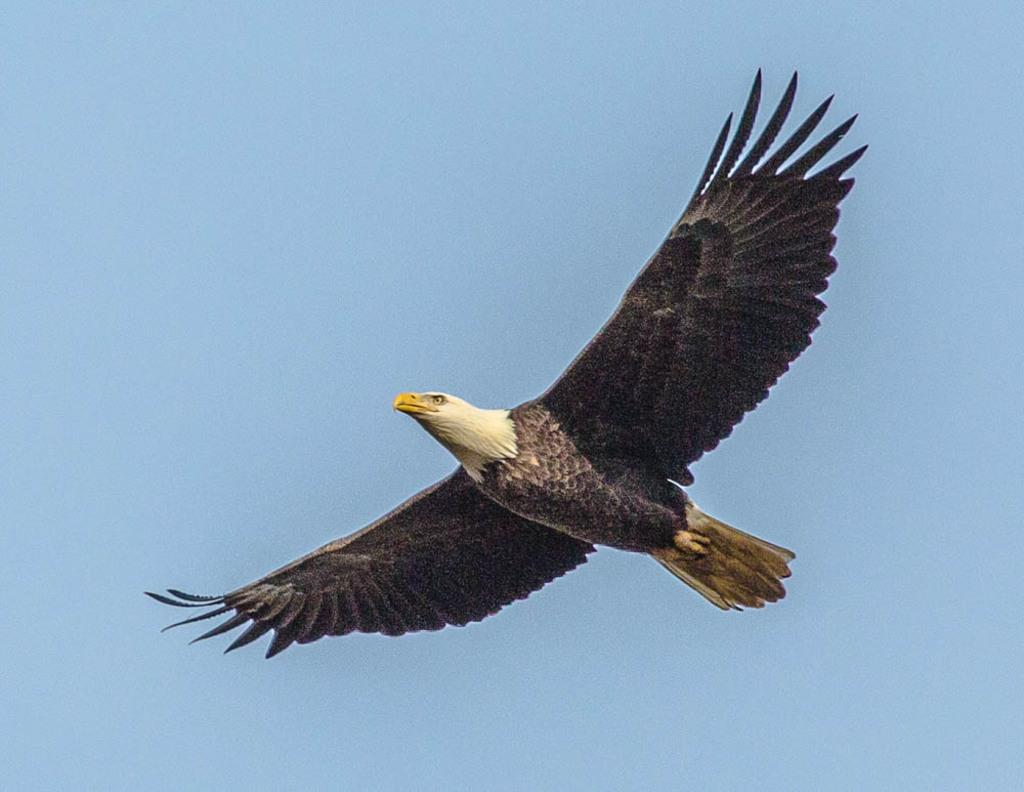What type of animal can be seen in the image? There is a bird in the image. What is the bird doing in the image? The bird is flying. What can be seen in the background of the image? The sky is visible behind the bird. What type of mouth can be seen on the bird in the image? There is no mouth visible on the bird in the image. What type of board is the bird using to fly in the image? The bird is not using a board to fly in the image; it is flying naturally. 